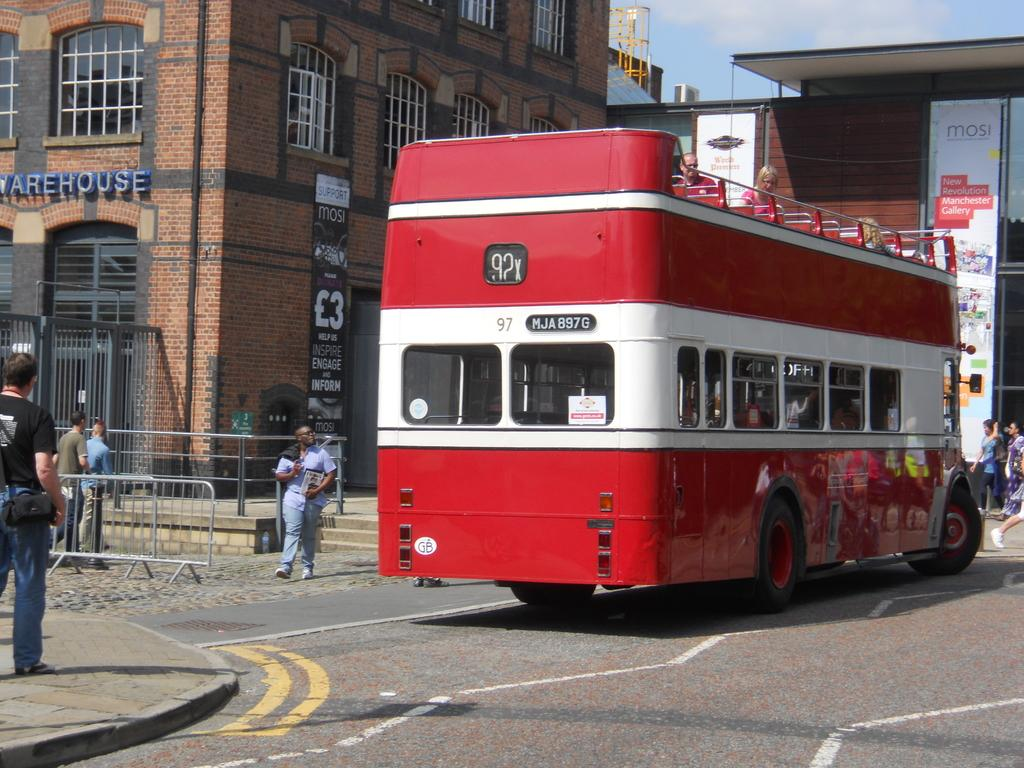<image>
Present a compact description of the photo's key features. A red bus passes in front of a building labeled warehouse. 